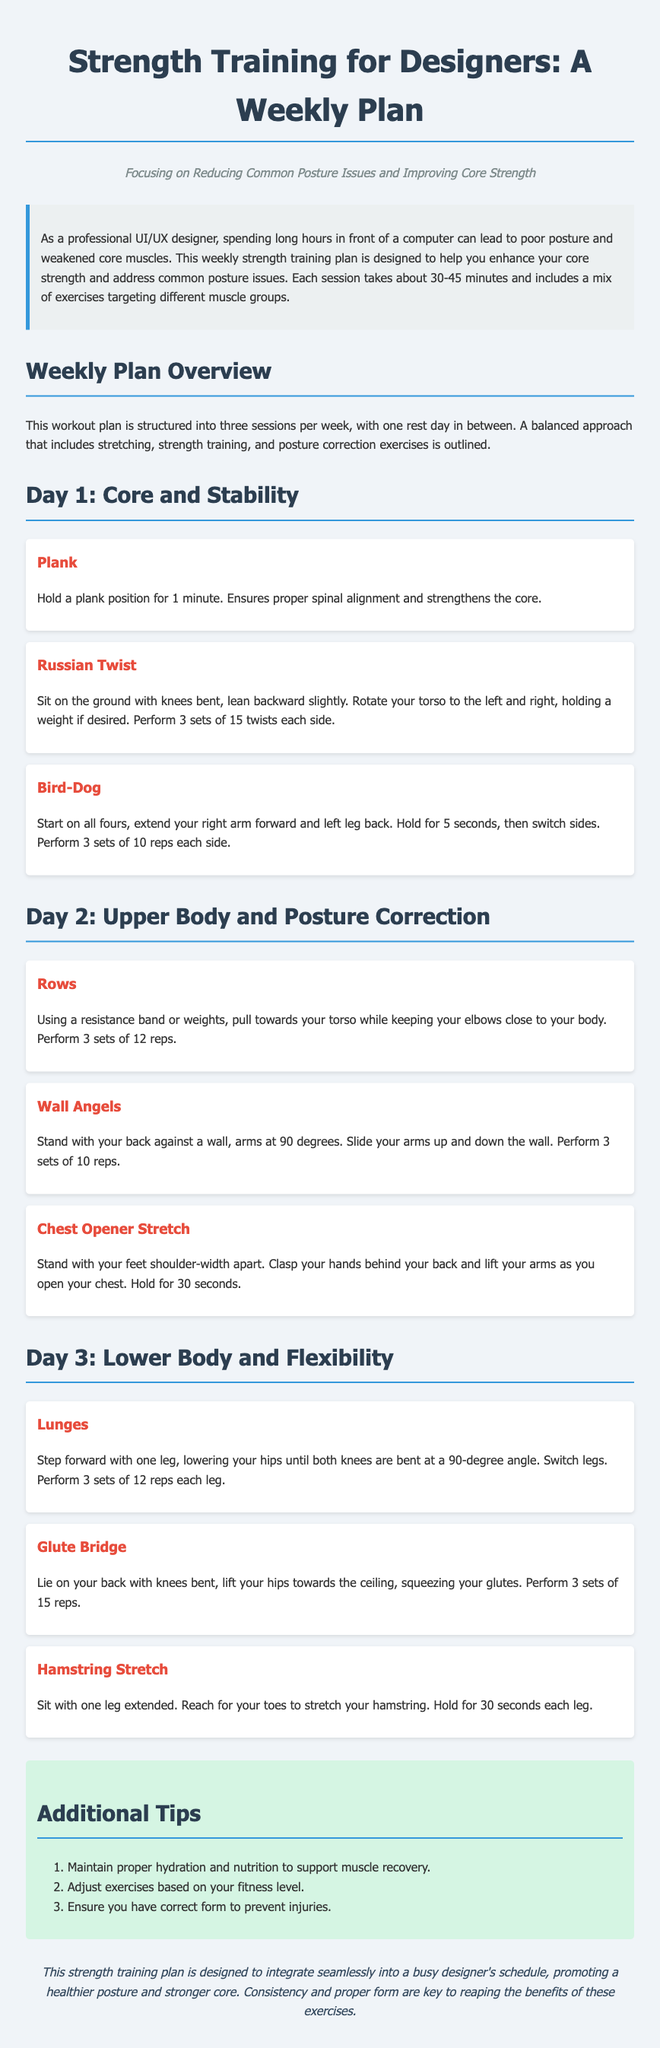What is the title of the document? The title appears prominently at the top of the rendered document.
Answer: Strength Training for Designers: A Weekly Plan How many sessions are included in the weekly plan? The weekly plan is structured into a specific frequency of sessions mentioned in the overview.
Answer: Three sessions What exercise requires holding a position for 1 minute? This exercise is distinctly described under Day 1 in the document.
Answer: Plank How many twists should be performed in the Russian Twist exercise? The number of sets and repetitions for this exercise is clearly stated in its description.
Answer: 15 twists each side What is the first exercise listed for Day 3? This exercise is the first item listed for the third day's workout in the document.
Answer: Lunges What is the primary focus of the workout plan? The document defines the aim of the plan in its subtitle and overview.
Answer: Reducing Common Posture Issues and Improving Core Strength How many reps are recommended for the Rows exercise? The number of repetitions for this exercise is provided in the detailed description.
Answer: 12 reps What is advised to maintain proper recovery? This information is provided in the tips section of the document.
Answer: Proper hydration and nutrition 